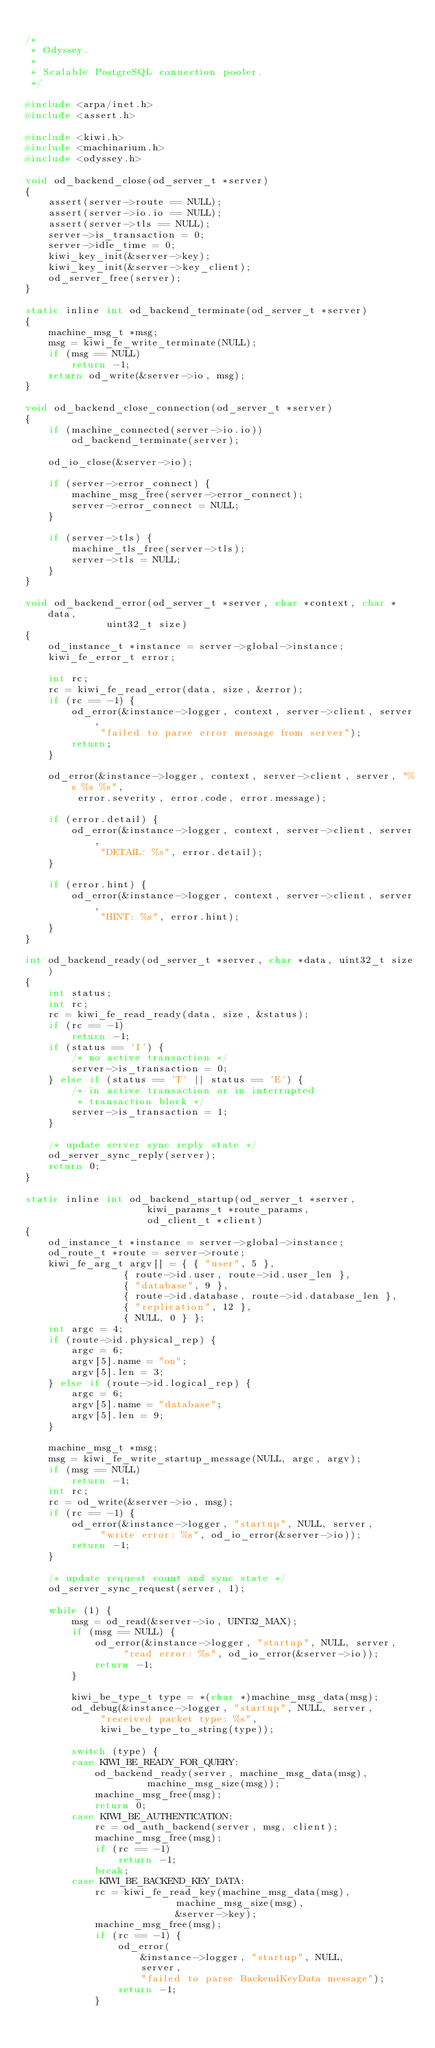<code> <loc_0><loc_0><loc_500><loc_500><_C_>
/*
 * Odyssey.
 *
 * Scalable PostgreSQL connection pooler.
 */

#include <arpa/inet.h>
#include <assert.h>

#include <kiwi.h>
#include <machinarium.h>
#include <odyssey.h>

void od_backend_close(od_server_t *server)
{
	assert(server->route == NULL);
	assert(server->io.io == NULL);
	assert(server->tls == NULL);
	server->is_transaction = 0;
	server->idle_time = 0;
	kiwi_key_init(&server->key);
	kiwi_key_init(&server->key_client);
	od_server_free(server);
}

static inline int od_backend_terminate(od_server_t *server)
{
	machine_msg_t *msg;
	msg = kiwi_fe_write_terminate(NULL);
	if (msg == NULL)
		return -1;
	return od_write(&server->io, msg);
}

void od_backend_close_connection(od_server_t *server)
{
	if (machine_connected(server->io.io))
		od_backend_terminate(server);

	od_io_close(&server->io);

	if (server->error_connect) {
		machine_msg_free(server->error_connect);
		server->error_connect = NULL;
	}

	if (server->tls) {
		machine_tls_free(server->tls);
		server->tls = NULL;
	}
}

void od_backend_error(od_server_t *server, char *context, char *data,
		      uint32_t size)
{
	od_instance_t *instance = server->global->instance;
	kiwi_fe_error_t error;

	int rc;
	rc = kiwi_fe_read_error(data, size, &error);
	if (rc == -1) {
		od_error(&instance->logger, context, server->client, server,
			 "failed to parse error message from server");
		return;
	}

	od_error(&instance->logger, context, server->client, server, "%s %s %s",
		 error.severity, error.code, error.message);

	if (error.detail) {
		od_error(&instance->logger, context, server->client, server,
			 "DETAIL: %s", error.detail);
	}

	if (error.hint) {
		od_error(&instance->logger, context, server->client, server,
			 "HINT: %s", error.hint);
	}
}

int od_backend_ready(od_server_t *server, char *data, uint32_t size)
{
	int status;
	int rc;
	rc = kiwi_fe_read_ready(data, size, &status);
	if (rc == -1)
		return -1;
	if (status == 'I') {
		/* no active transaction */
		server->is_transaction = 0;
	} else if (status == 'T' || status == 'E') {
		/* in active transaction or in interrupted
		 * transaction block */
		server->is_transaction = 1;
	}

	/* update server sync reply state */
	od_server_sync_reply(server);
	return 0;
}

static inline int od_backend_startup(od_server_t *server,
				     kiwi_params_t *route_params,
				     od_client_t *client)
{
	od_instance_t *instance = server->global->instance;
	od_route_t *route = server->route;
	kiwi_fe_arg_t argv[] = { { "user", 5 },
				 { route->id.user, route->id.user_len },
				 { "database", 9 },
				 { route->id.database, route->id.database_len },
				 { "replication", 12 },
				 { NULL, 0 } };
	int argc = 4;
	if (route->id.physical_rep) {
		argc = 6;
		argv[5].name = "on";
		argv[5].len = 3;
	} else if (route->id.logical_rep) {
		argc = 6;
		argv[5].name = "database";
		argv[5].len = 9;
	}

	machine_msg_t *msg;
	msg = kiwi_fe_write_startup_message(NULL, argc, argv);
	if (msg == NULL)
		return -1;
	int rc;
	rc = od_write(&server->io, msg);
	if (rc == -1) {
		od_error(&instance->logger, "startup", NULL, server,
			 "write error: %s", od_io_error(&server->io));
		return -1;
	}

	/* update request count and sync state */
	od_server_sync_request(server, 1);

	while (1) {
		msg = od_read(&server->io, UINT32_MAX);
		if (msg == NULL) {
			od_error(&instance->logger, "startup", NULL, server,
				 "read error: %s", od_io_error(&server->io));
			return -1;
		}

		kiwi_be_type_t type = *(char *)machine_msg_data(msg);
		od_debug(&instance->logger, "startup", NULL, server,
			 "received packet type: %s",
			 kiwi_be_type_to_string(type));

		switch (type) {
		case KIWI_BE_READY_FOR_QUERY:
			od_backend_ready(server, machine_msg_data(msg),
					 machine_msg_size(msg));
			machine_msg_free(msg);
			return 0;
		case KIWI_BE_AUTHENTICATION:
			rc = od_auth_backend(server, msg, client);
			machine_msg_free(msg);
			if (rc == -1)
				return -1;
			break;
		case KIWI_BE_BACKEND_KEY_DATA:
			rc = kiwi_fe_read_key(machine_msg_data(msg),
					      machine_msg_size(msg),
					      &server->key);
			machine_msg_free(msg);
			if (rc == -1) {
				od_error(
					&instance->logger, "startup", NULL,
					server,
					"failed to parse BackendKeyData message");
				return -1;
			}</code> 